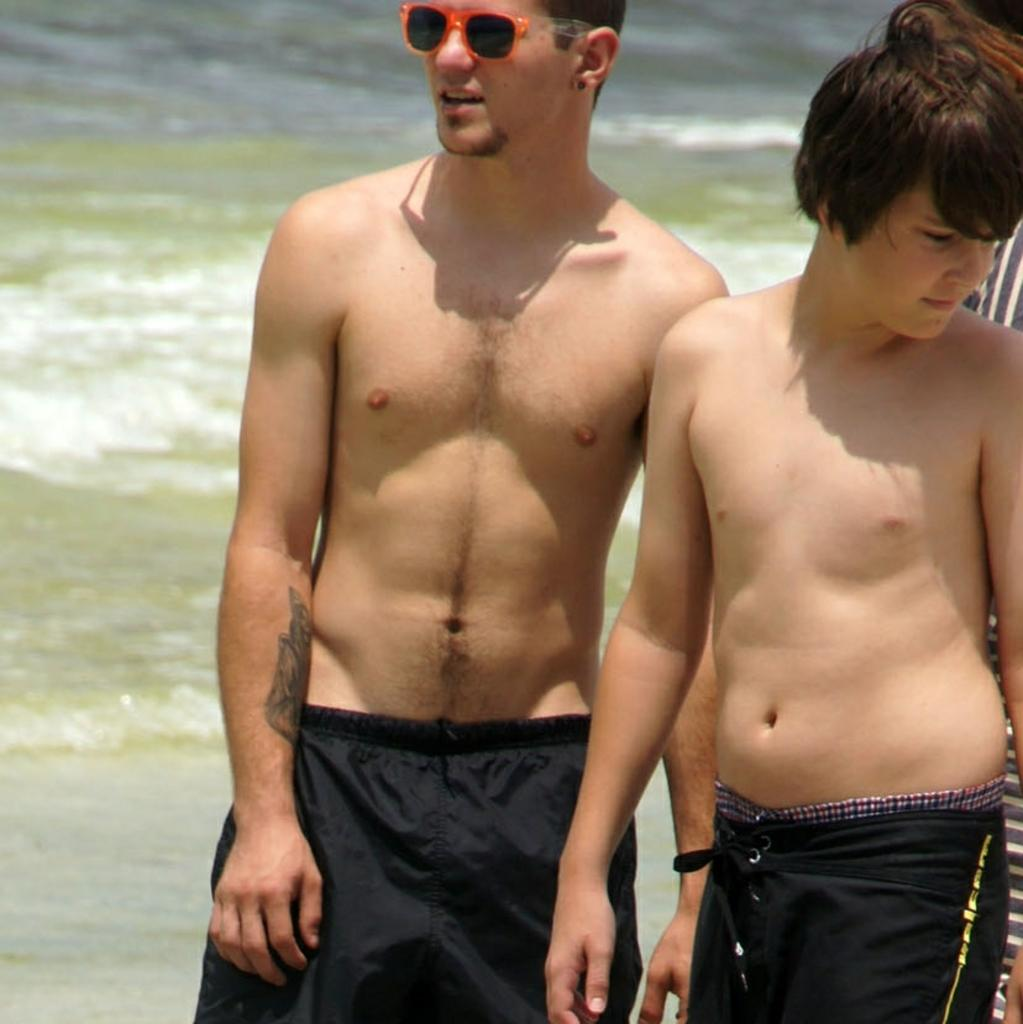What are the two persons in the image doing? The two persons in the image are standing without shirts. Can you describe the third person in the image? There is another person behind them in the image. What can be seen in the background of the image? There is water visible in the background of the image. What is the price of the ice in the image? There is no ice present in the image, so it is not possible to determine the price. 